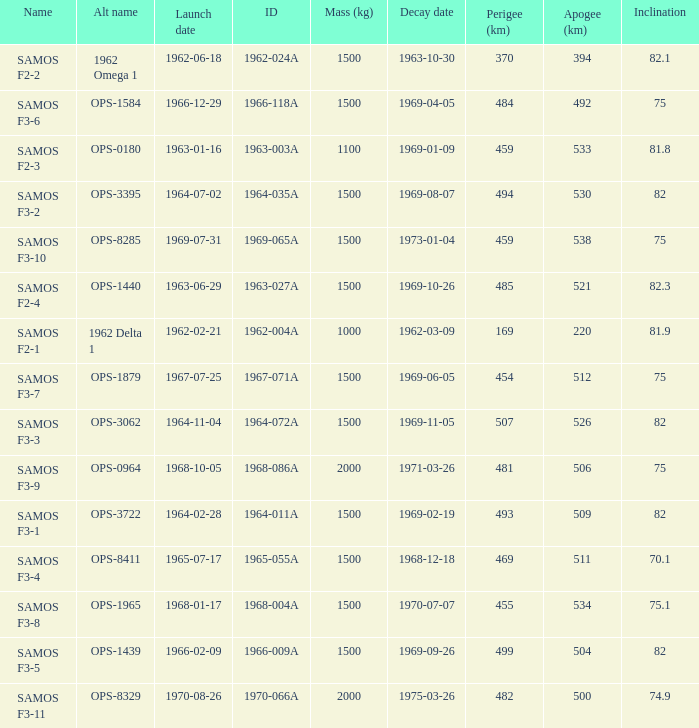What was the maximum perigee on 1969-01-09? 459.0. 